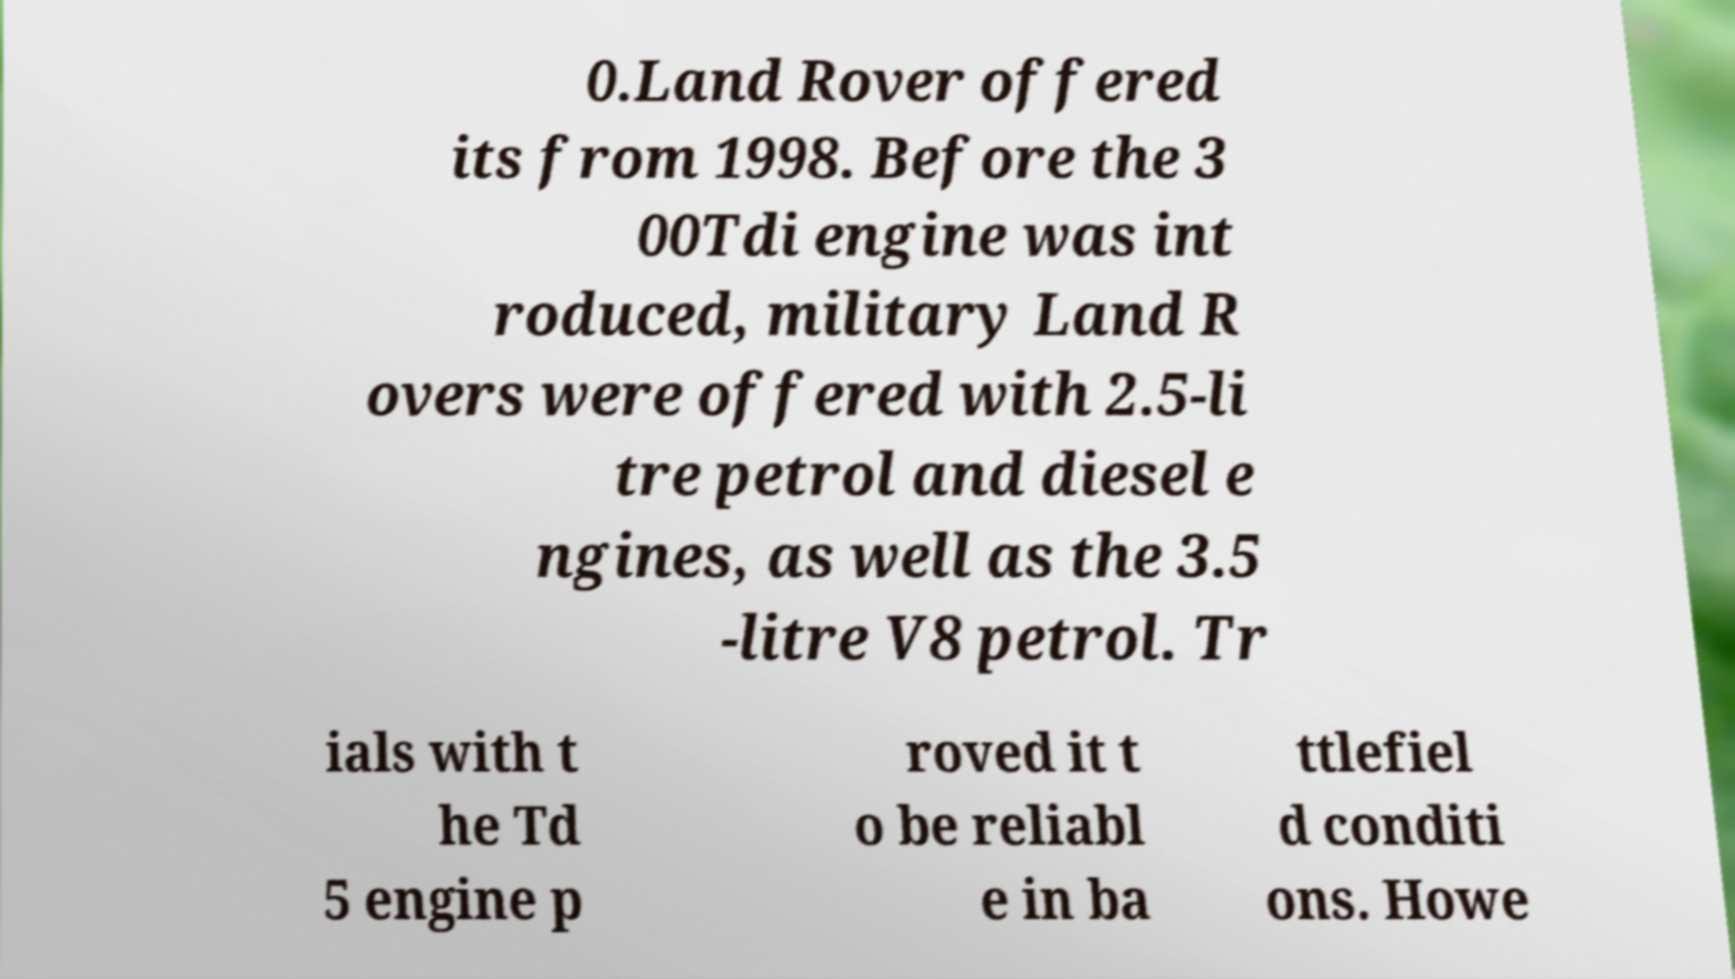Please read and relay the text visible in this image. What does it say? 0.Land Rover offered its from 1998. Before the 3 00Tdi engine was int roduced, military Land R overs were offered with 2.5-li tre petrol and diesel e ngines, as well as the 3.5 -litre V8 petrol. Tr ials with t he Td 5 engine p roved it t o be reliabl e in ba ttlefiel d conditi ons. Howe 